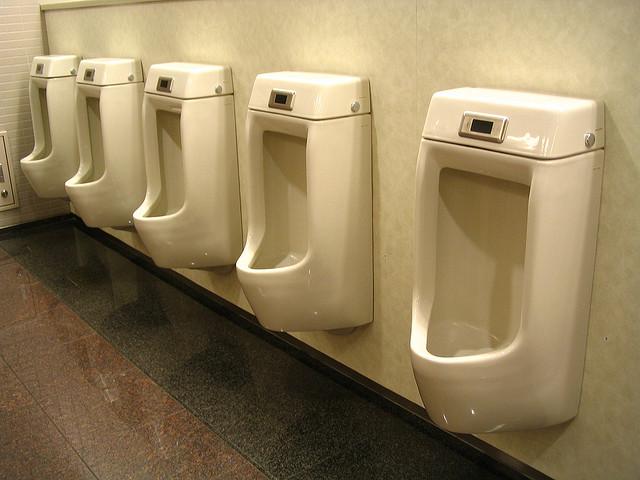Is this bathroom clean?
Give a very brief answer. Yes. Is this a bathroom in a home?
Give a very brief answer. No. Is this something women would use?
Quick response, please. No. 